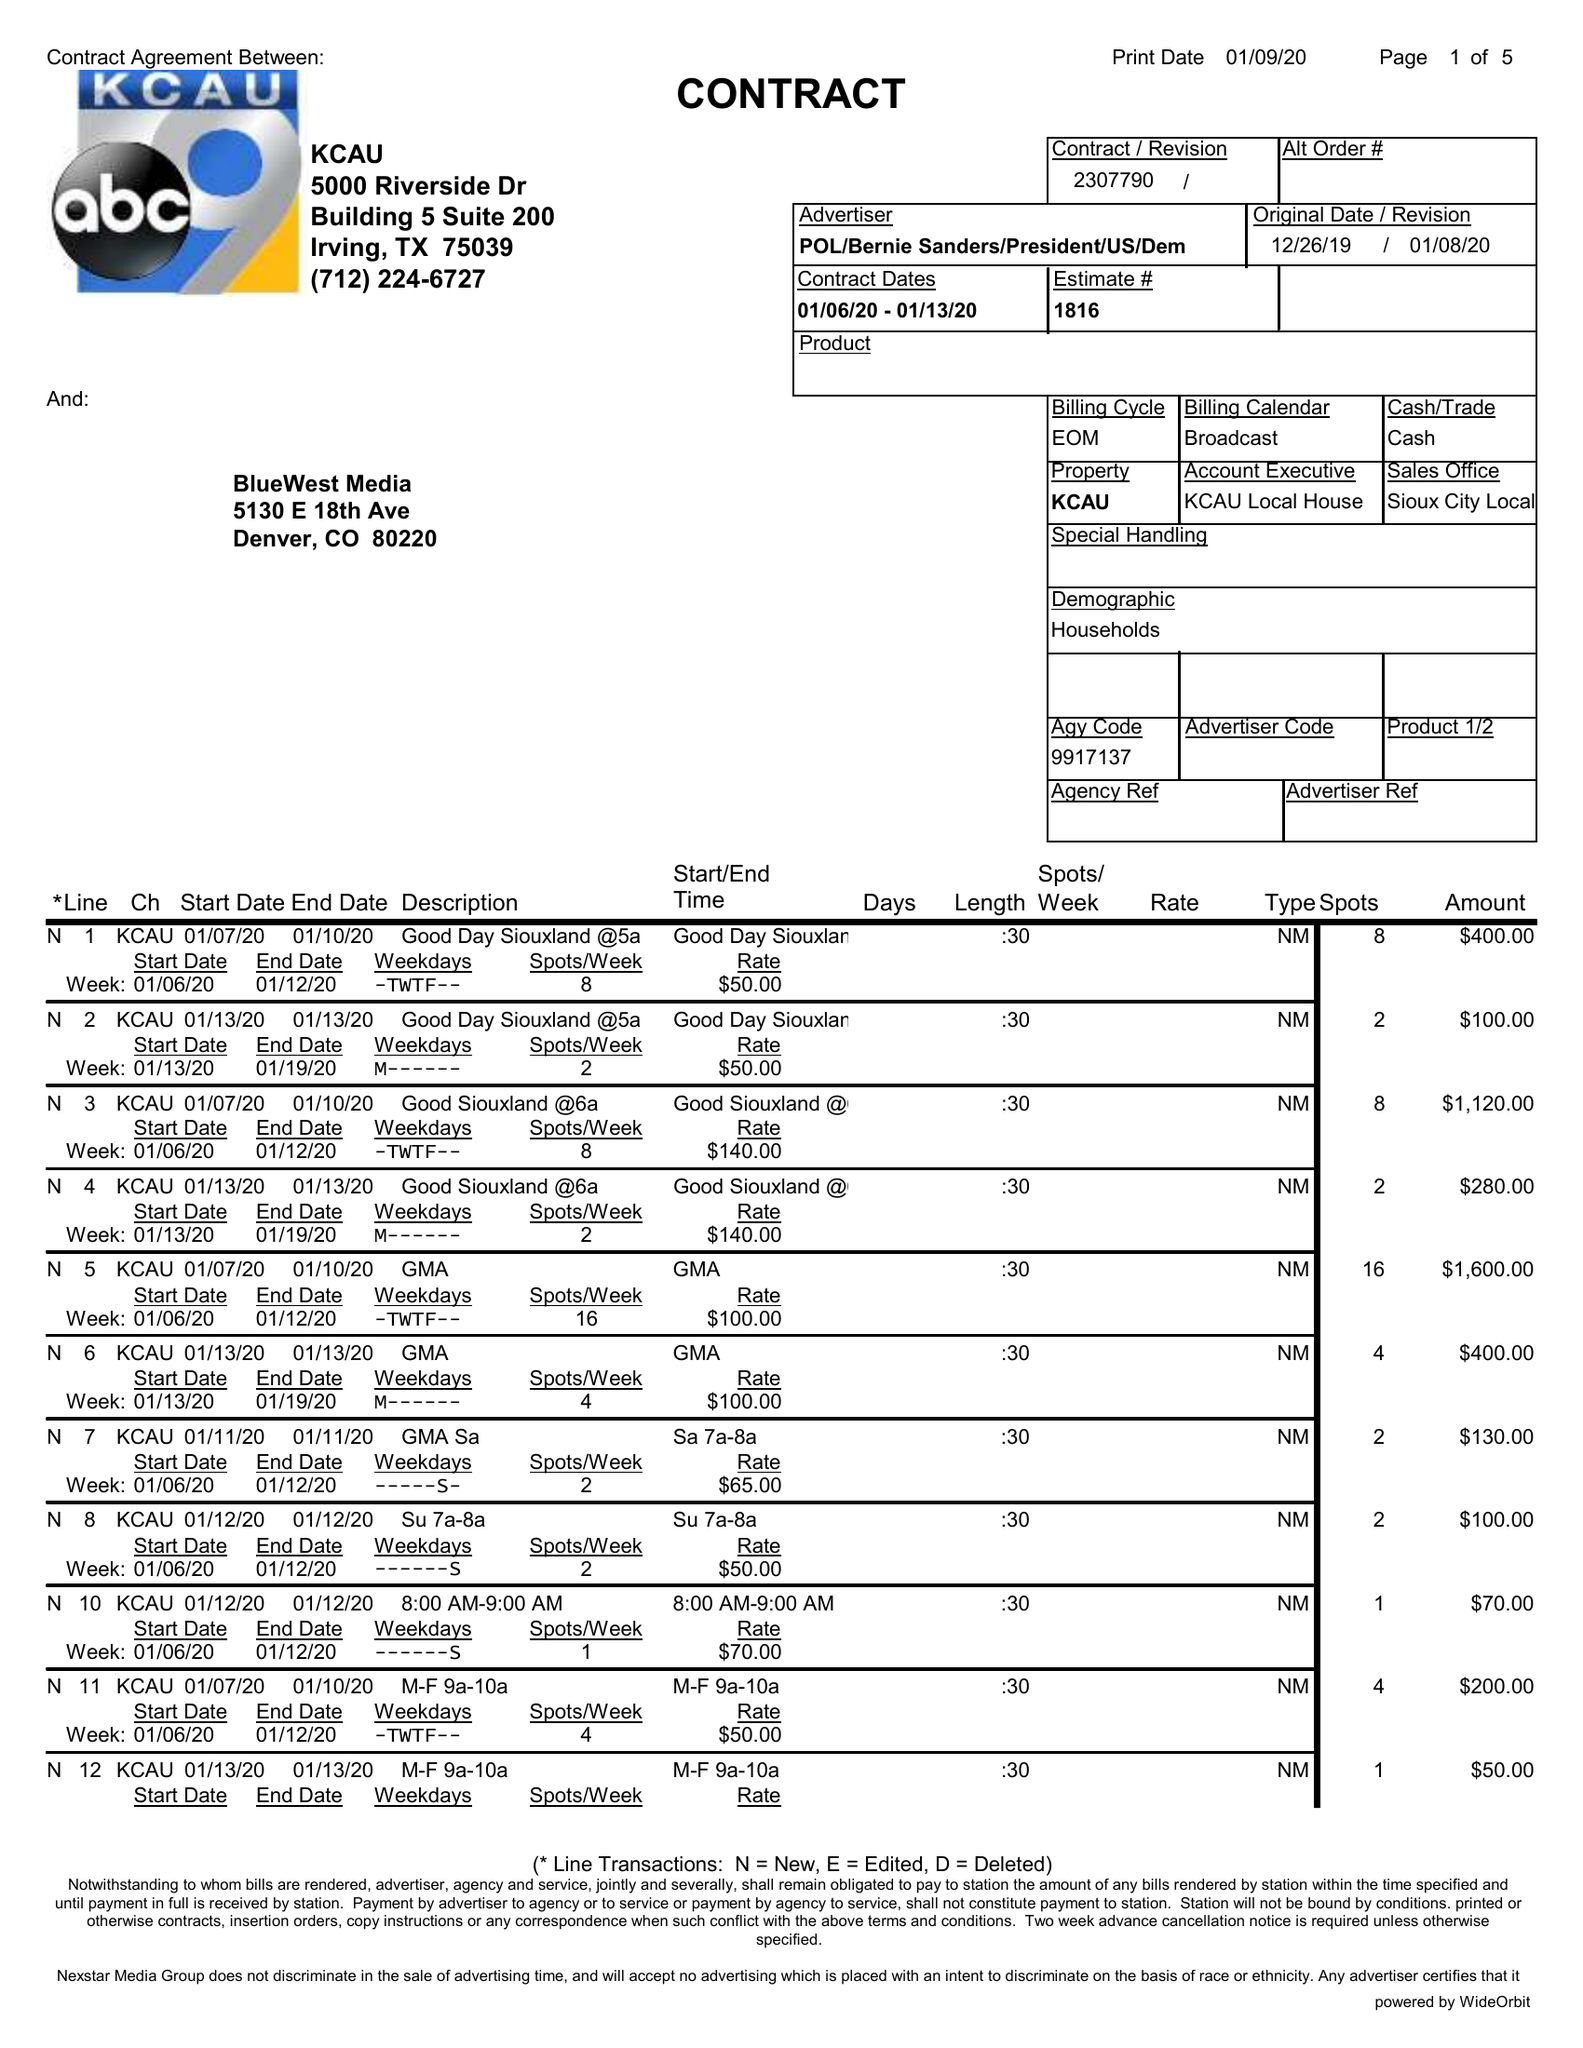What is the value for the flight_to?
Answer the question using a single word or phrase. 01/13/20 